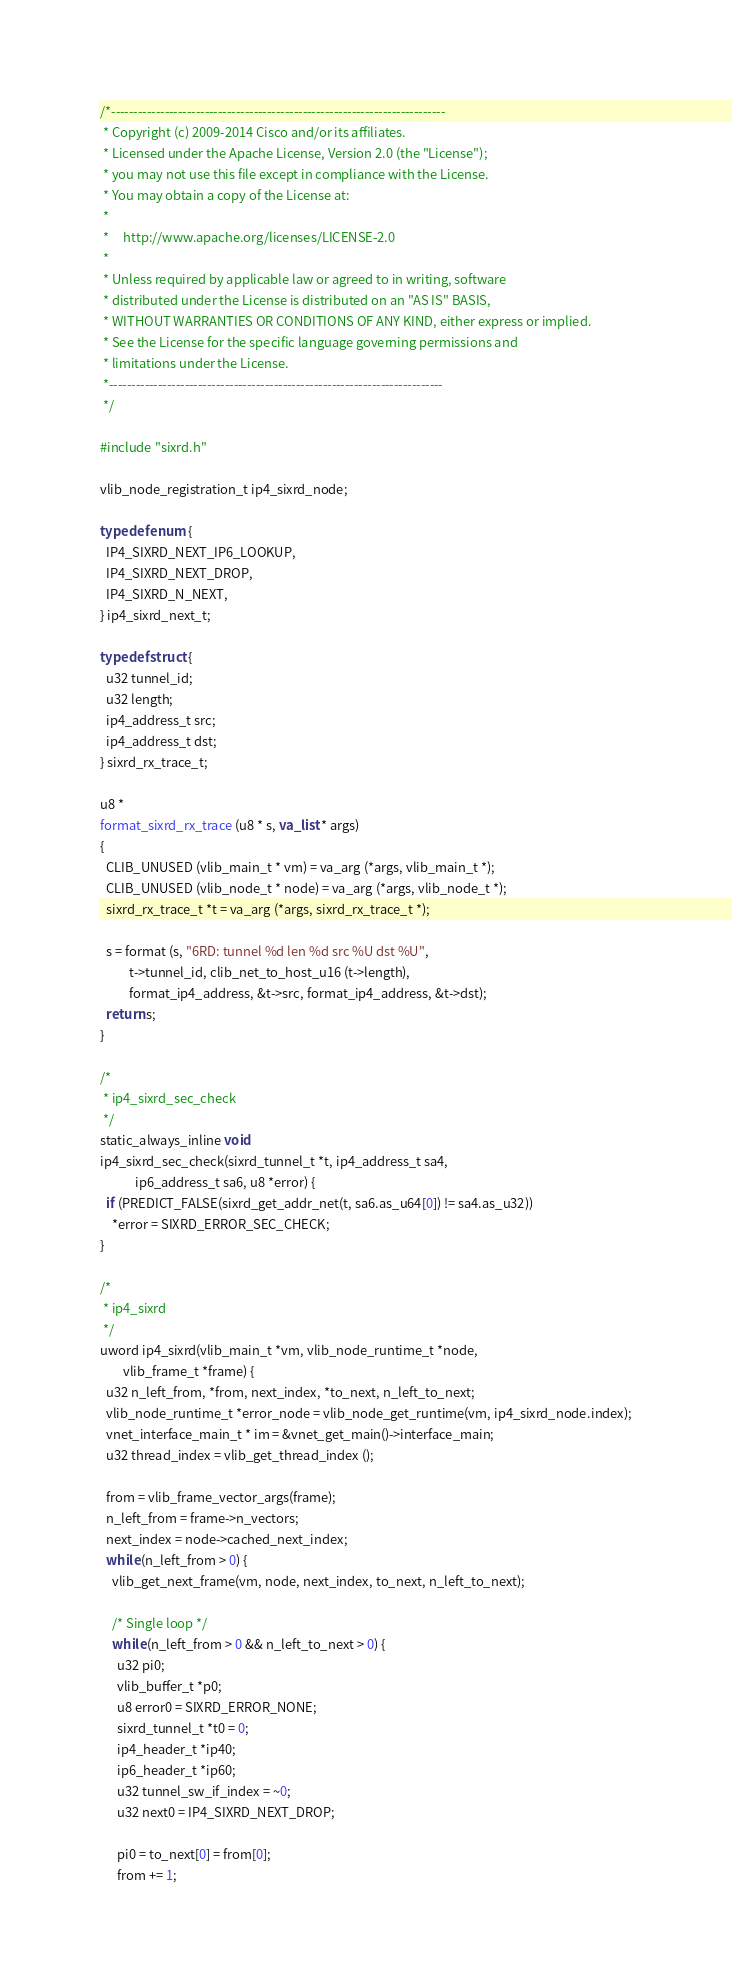<code> <loc_0><loc_0><loc_500><loc_500><_C_>/*---------------------------------------------------------------------------
 * Copyright (c) 2009-2014 Cisco and/or its affiliates.
 * Licensed under the Apache License, Version 2.0 (the "License");
 * you may not use this file except in compliance with the License.
 * You may obtain a copy of the License at:
 *
 *     http://www.apache.org/licenses/LICENSE-2.0
 *
 * Unless required by applicable law or agreed to in writing, software
 * distributed under the License is distributed on an "AS IS" BASIS,
 * WITHOUT WARRANTIES OR CONDITIONS OF ANY KIND, either express or implied.
 * See the License for the specific language governing permissions and
 * limitations under the License.
 *---------------------------------------------------------------------------
 */

#include "sixrd.h"

vlib_node_registration_t ip4_sixrd_node;

typedef enum {
  IP4_SIXRD_NEXT_IP6_LOOKUP,
  IP4_SIXRD_NEXT_DROP,
  IP4_SIXRD_N_NEXT,
} ip4_sixrd_next_t;

typedef struct {
  u32 tunnel_id;
  u32 length;
  ip4_address_t src;
  ip4_address_t dst;
} sixrd_rx_trace_t;

u8 *
format_sixrd_rx_trace (u8 * s, va_list * args)
{
  CLIB_UNUSED (vlib_main_t * vm) = va_arg (*args, vlib_main_t *);
  CLIB_UNUSED (vlib_node_t * node) = va_arg (*args, vlib_node_t *);
  sixrd_rx_trace_t *t = va_arg (*args, sixrd_rx_trace_t *);

  s = format (s, "6RD: tunnel %d len %d src %U dst %U",
	      t->tunnel_id, clib_net_to_host_u16 (t->length),
	      format_ip4_address, &t->src, format_ip4_address, &t->dst);
  return s;
}

/*
 * ip4_sixrd_sec_check
 */
static_always_inline void
ip4_sixrd_sec_check(sixrd_tunnel_t *t, ip4_address_t sa4,
		    ip6_address_t sa6, u8 *error) {
  if (PREDICT_FALSE(sixrd_get_addr_net(t, sa6.as_u64[0]) != sa4.as_u32))
    *error = SIXRD_ERROR_SEC_CHECK;
}

/*
 * ip4_sixrd
 */
uword ip4_sixrd(vlib_main_t *vm, vlib_node_runtime_t *node,
		vlib_frame_t *frame) {
  u32 n_left_from, *from, next_index, *to_next, n_left_to_next;
  vlib_node_runtime_t *error_node = vlib_node_get_runtime(vm, ip4_sixrd_node.index);
  vnet_interface_main_t * im = &vnet_get_main()->interface_main;
  u32 thread_index = vlib_get_thread_index ();

  from = vlib_frame_vector_args(frame);
  n_left_from = frame->n_vectors;
  next_index = node->cached_next_index;
  while (n_left_from > 0) {
    vlib_get_next_frame(vm, node, next_index, to_next, n_left_to_next);

    /* Single loop */
    while (n_left_from > 0 && n_left_to_next > 0) {
      u32 pi0;
      vlib_buffer_t *p0;
      u8 error0 = SIXRD_ERROR_NONE;
      sixrd_tunnel_t *t0 = 0;
      ip4_header_t *ip40;
      ip6_header_t *ip60;
      u32 tunnel_sw_if_index = ~0;
      u32 next0 = IP4_SIXRD_NEXT_DROP;

      pi0 = to_next[0] = from[0];
      from += 1;</code> 